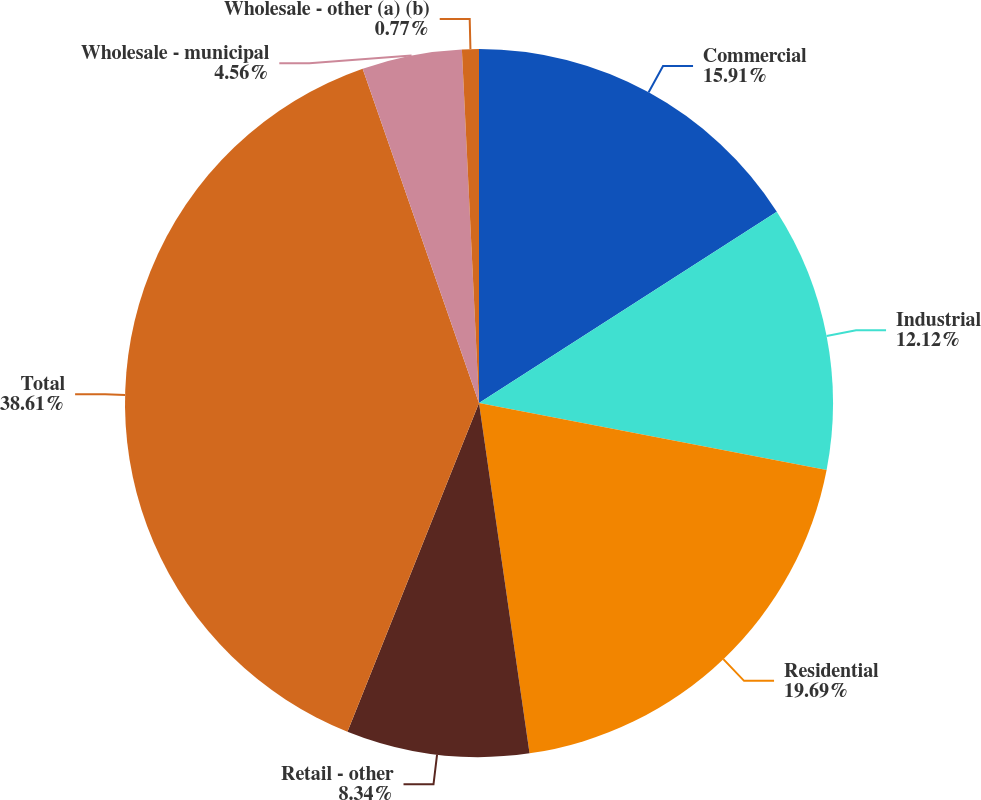Convert chart. <chart><loc_0><loc_0><loc_500><loc_500><pie_chart><fcel>Commercial<fcel>Industrial<fcel>Residential<fcel>Retail - other<fcel>Total<fcel>Wholesale - municipal<fcel>Wholesale - other (a) (b)<nl><fcel>15.91%<fcel>12.12%<fcel>19.69%<fcel>8.34%<fcel>38.61%<fcel>4.56%<fcel>0.77%<nl></chart> 